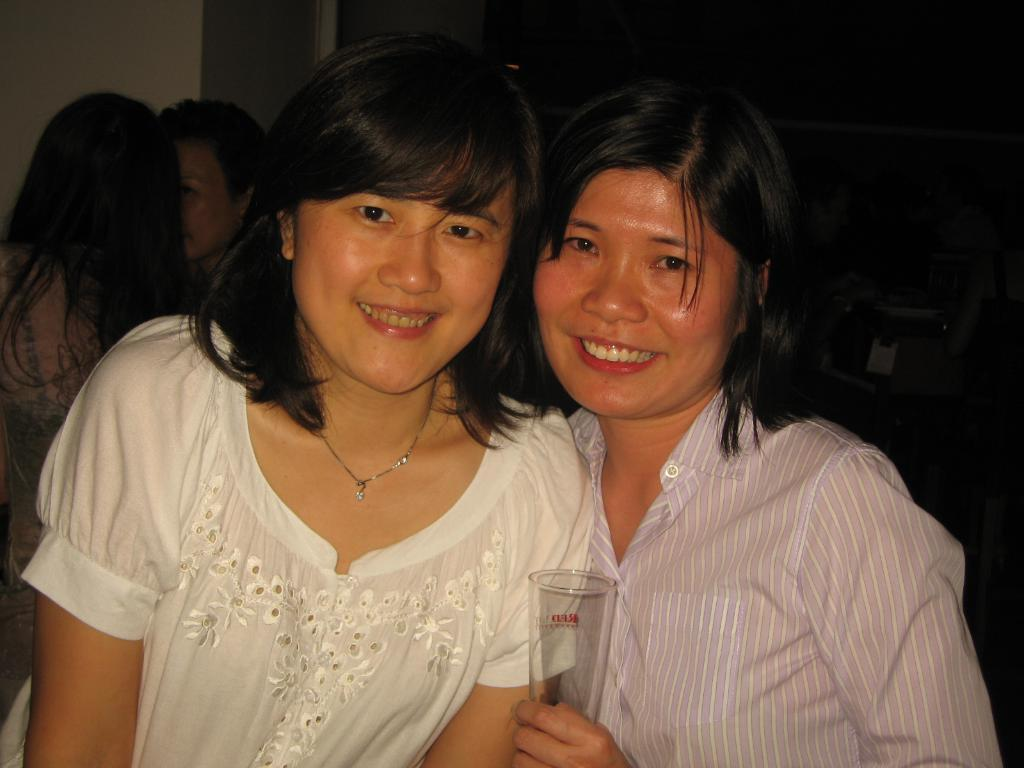How many people are in the image? There are people in the image, but the exact number is not specified. What is one of the people holding? One of the people is holding a glass. What can be seen in the background of the image? There is a wall in the background of the image. What type of seed is being blown by the wind in the image? There is no seed or wind present in the image; it only features people and a wall in the background. 